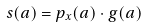<formula> <loc_0><loc_0><loc_500><loc_500>s ( a ) = p _ { x } ( a ) \cdot g ( a )</formula> 